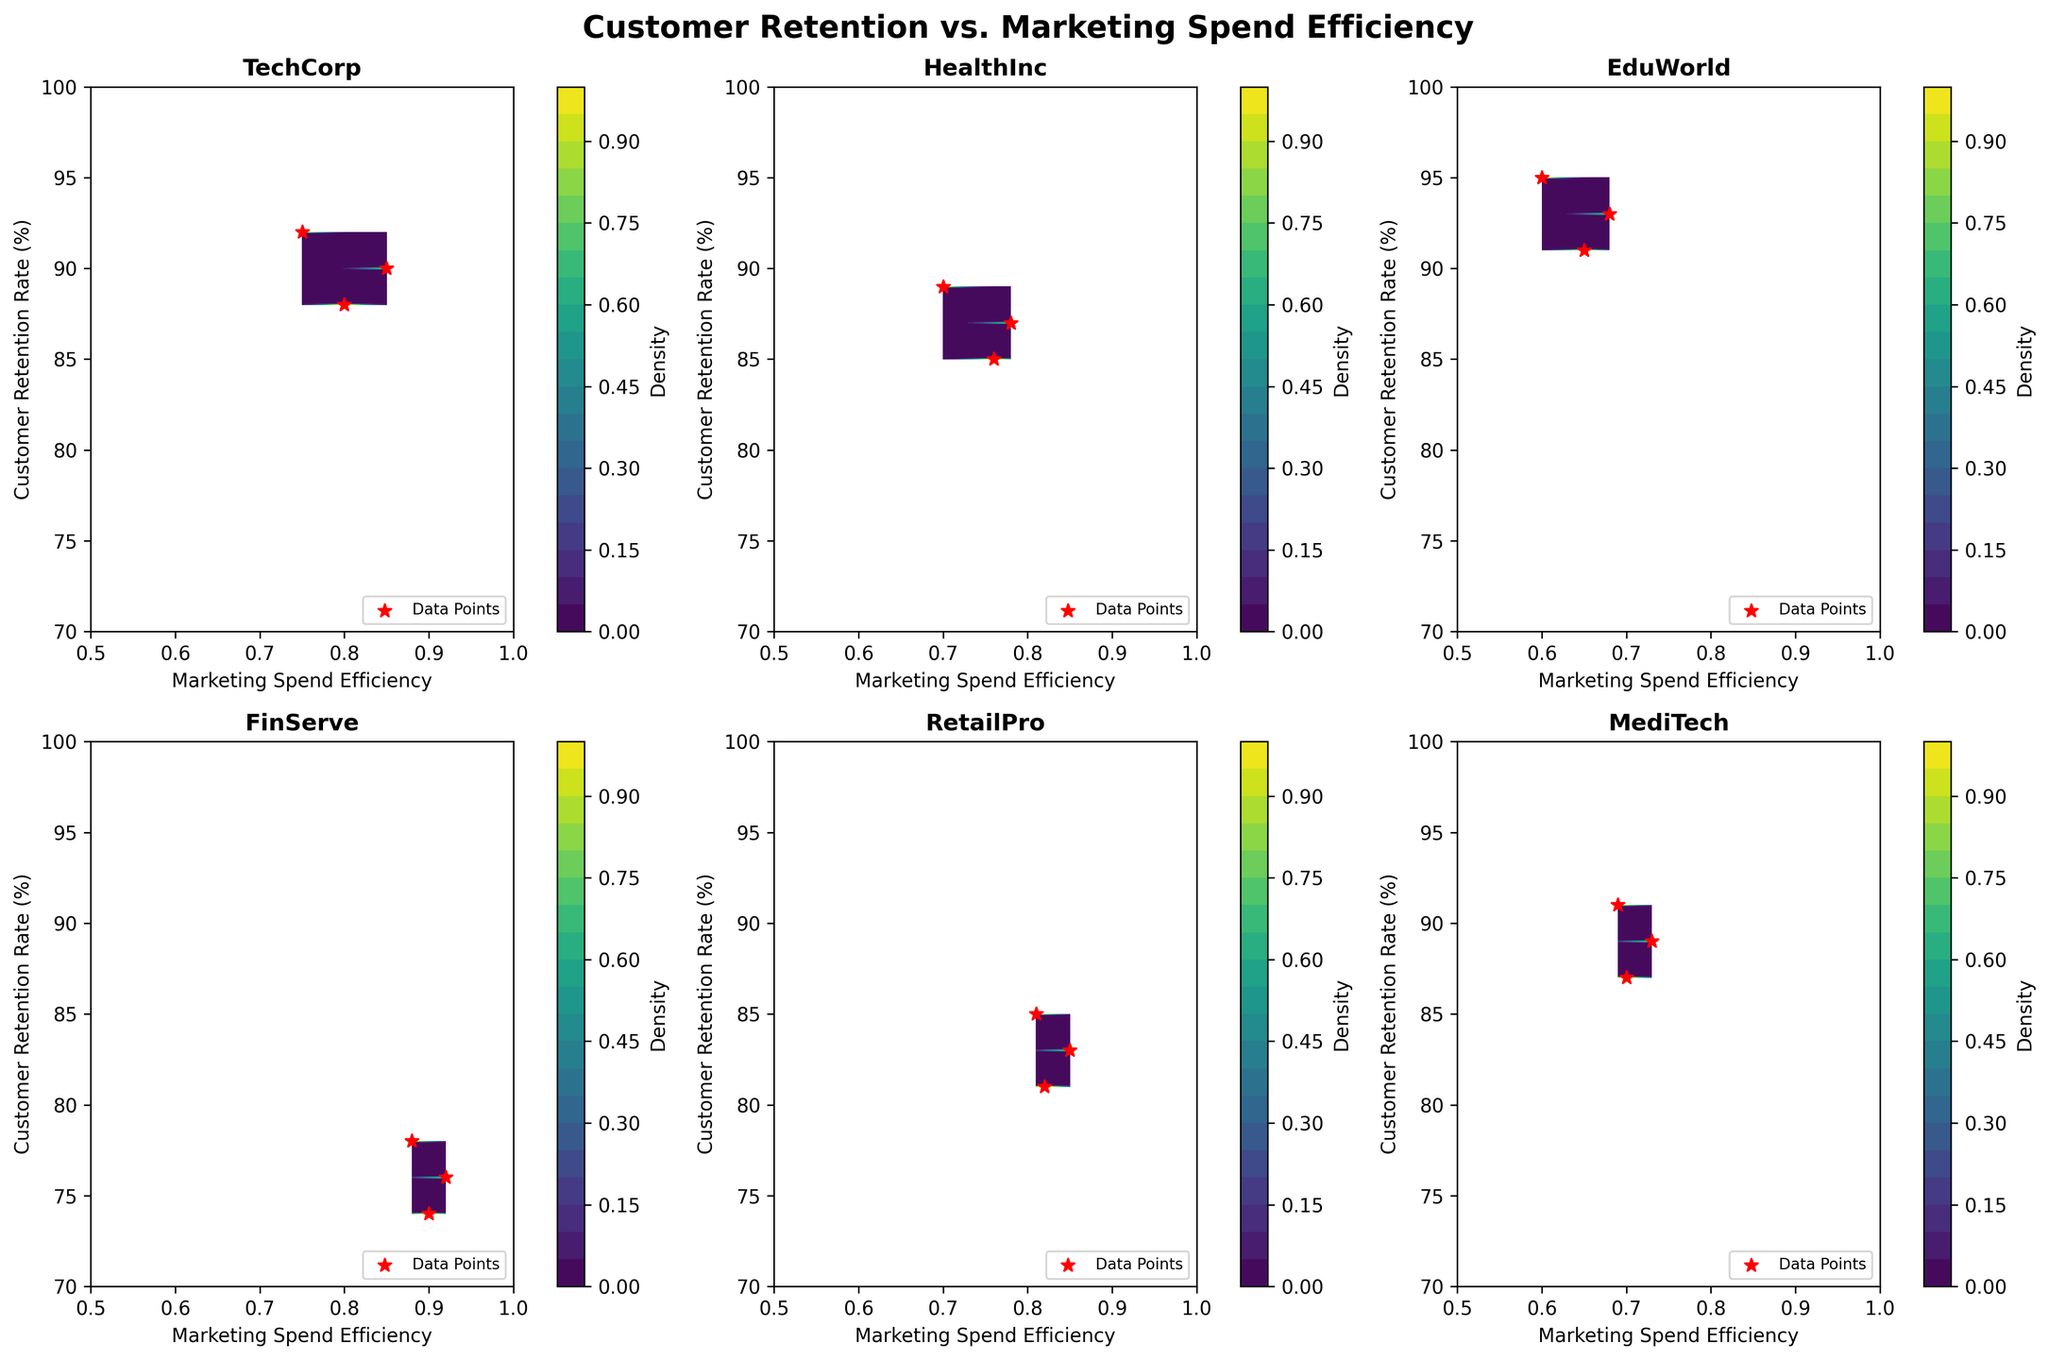What is the title of the plot? The title is centered at the top of the figure and clearly states the main focus of the plots.
Answer: Customer Retention vs. Marketing Spend Efficiency How many subplots are there in the figure? There are six individual subplots arranged in a 2x3 grid.
Answer: Six Which company has the highest marketing spend efficiency in the initial integration phase? From the subplot titled 'FinServe', the marketing spend efficiency in the initial phase is the highest, at 0.88.
Answer: FinServe Which company shows a higher customer retention rate in the final phase between TechCorp and HealthInc? Comparing the subplots titled 'TechCorp' and 'HealthInc', TechCorp shows a higher customer retention rate (88%) in the final phase compared to HealthInc (85%).
Answer: TechCorp What is the range for the x-axis? The x-axis labels indicate the range from 0.5 to 1.0 for all subplots.
Answer: 0.5 to 1.0 In which integration phase does RetailPro display the highest customer retention rate? From the subplot titled 'RetailPro', the initial phase shows the highest customer retention rate at 85%.
Answer: Initial Compare the density distribution of Marketing Spend Efficiency between TechCorp and EduWorld. Which one is more concentrated and where? TechCorp's density distribution is more concentrated around the high values of marketing spend efficiency, close to 0.85, while EduWorld's density distribution is more spread out towards lower values.
Answer: TechCorp around 0.85 Which company has the steepest decline in customer retention rate from the initial to final phase? By observing the scatter points in the subplots, FinServe shows the steepest decline from 78% to 74%.
Answer: FinServe Which subplot shows the closest clustering of data points? The subplot for RetailPro shows closely clustered data points with less spread in both axes.
Answer: RetailPro Do the colors on the contour plots represent different density levels? Yes, the varying shades in the contour plots represent different density levels of customer retention rates and marketing spend efficiency combinations.
Answer: Yes 